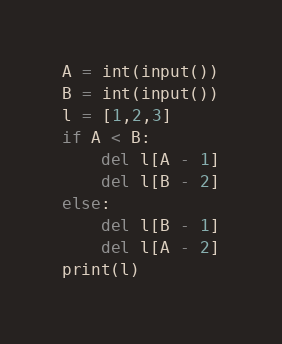Convert code to text. <code><loc_0><loc_0><loc_500><loc_500><_Python_>A = int(input())
B = int(input())
l = [1,2,3]
if A < B:
    del l[A - 1]
    del l[B - 2]
else:
    del l[B - 1]
    del l[A - 2]
print(l)</code> 